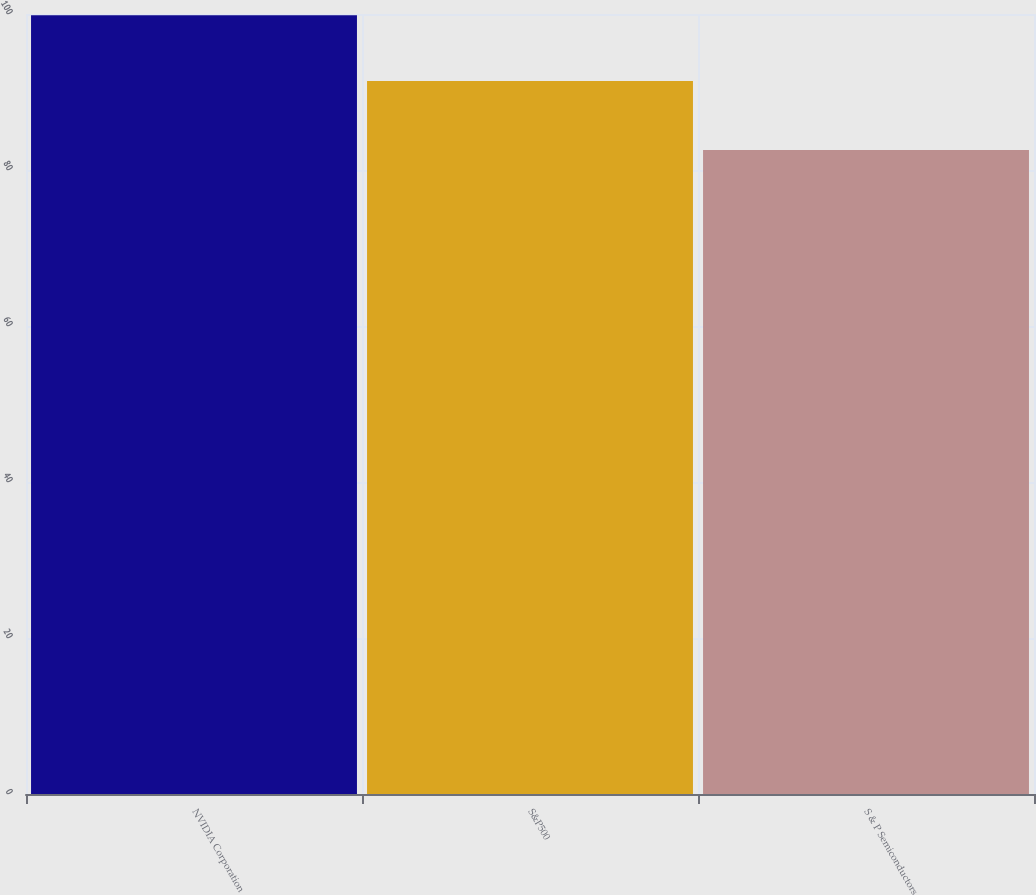Convert chart to OTSL. <chart><loc_0><loc_0><loc_500><loc_500><bar_chart><fcel>NVIDIA Corporation<fcel>S&P500<fcel>S & P Semiconductors<nl><fcel>99.83<fcel>91.41<fcel>82.57<nl></chart> 